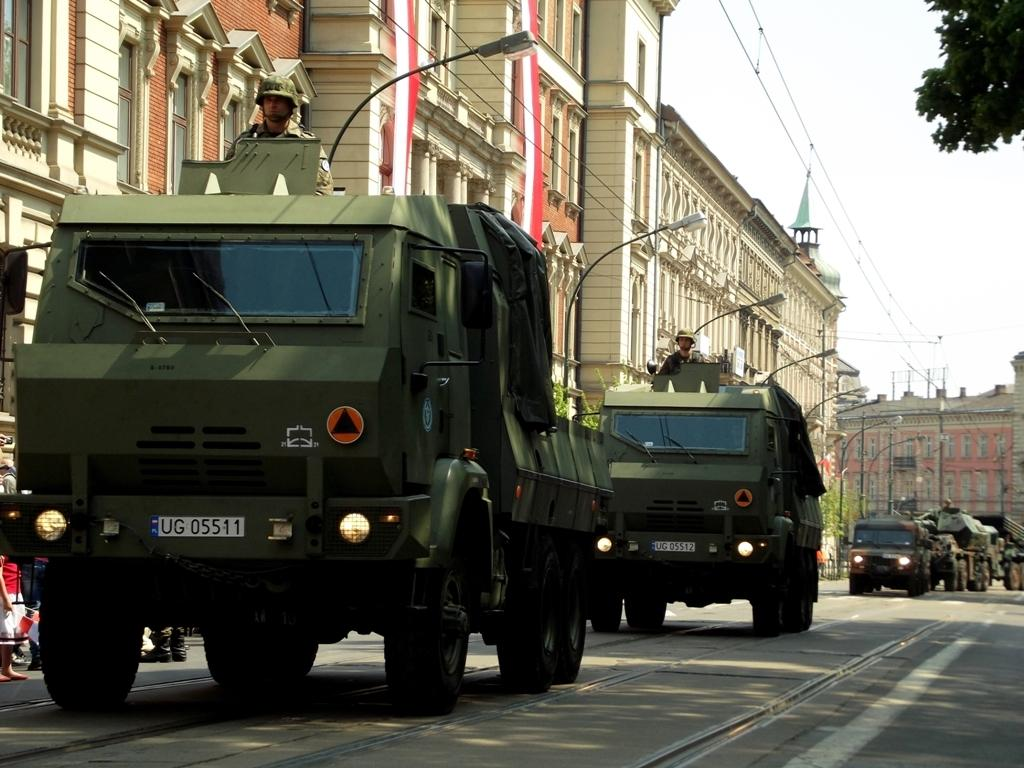What type of people can be seen in the vehicles in the image? There are army people in the vehicles. Where are the vehicles located in the image? The vehicles are on the road. What can be seen in the background of the image? There are buildings and trees visible in the image. What type of jeans are the army people wearing in the image? The image does not provide information about the type of jeans the army people might be wearing, as it focuses on the vehicles and their location. 